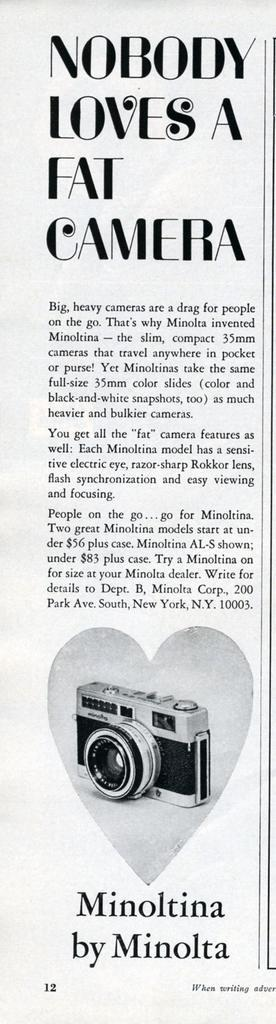What is the main object in the image? There is a paper in the image. What is depicted on the paper? There is a picture of a camera printed on the paper. Are there any words or letters on the paper? Yes, there is text on the paper. How many sacks can be seen in the image? There are no sacks present in the image. What type of memory is being stored in the camera depicted on the paper? The image does not provide information about the memory being stored in the camera; it only shows a picture of a camera. 